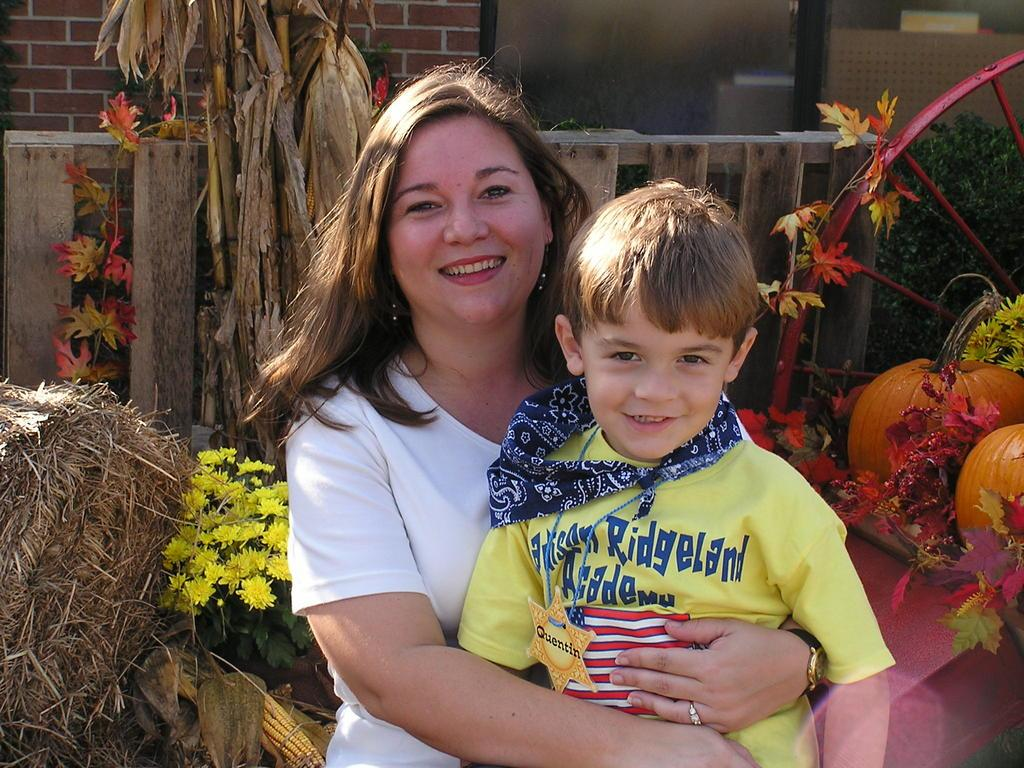Who is the main subject in the image? There is a woman in the image. What is the woman doing in the image? The woman is holding a kid in her hands. What type of plants can be seen in the image? There are flowers visible in the image. Where are the pumpkins located in the image? There are two pumpkins in the right corner of the image. What type of tomatoes can be seen growing on the woman's feet in the image? There are no tomatoes or any plants growing on the woman's feet in the image. 